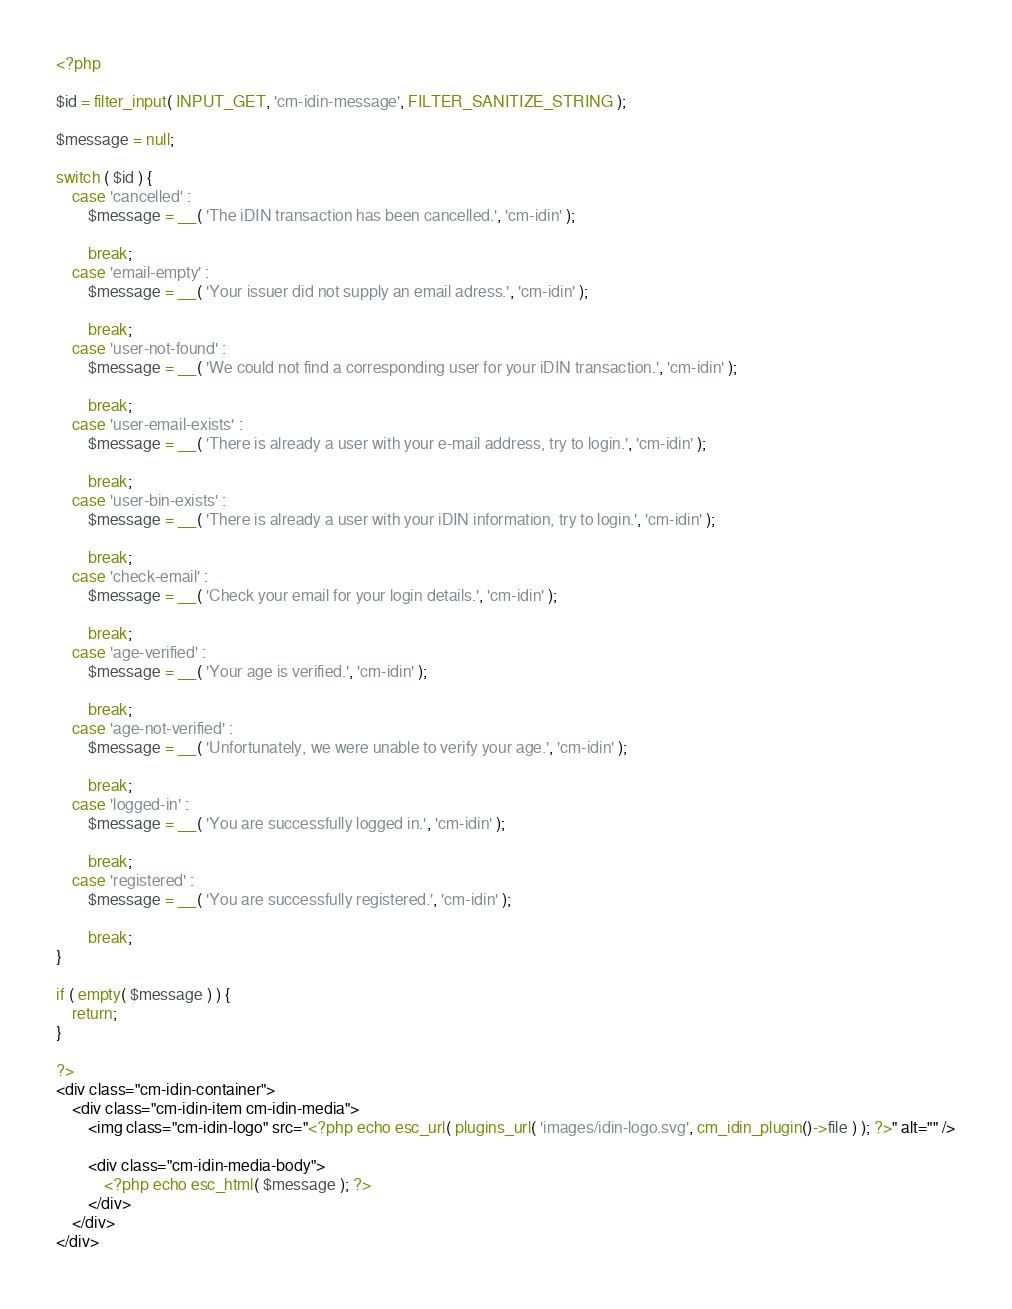<code> <loc_0><loc_0><loc_500><loc_500><_PHP_><?php

$id = filter_input( INPUT_GET, 'cm-idin-message', FILTER_SANITIZE_STRING );

$message = null;

switch ( $id ) {
	case 'cancelled' :
		$message = __( 'The iDIN transaction has been cancelled.', 'cm-idin' );

		break;
	case 'email-empty' :
		$message = __( 'Your issuer did not supply an email adress.', 'cm-idin' );

		break;
	case 'user-not-found' :
		$message = __( 'We could not find a corresponding user for your iDIN transaction.', 'cm-idin' );

		break;
	case 'user-email-exists' :
		$message = __( 'There is already a user with your e-mail address, try to login.', 'cm-idin' );

		break;
	case 'user-bin-exists' :
		$message = __( 'There is already a user with your iDIN information, try to login.', 'cm-idin' );

		break;
	case 'check-email' :
		$message = __( 'Check your email for your login details.', 'cm-idin' );

		break;
	case 'age-verified' :
		$message = __( 'Your age is verified.', 'cm-idin' );

		break;
	case 'age-not-verified' :
		$message = __( 'Unfortunately, we were unable to verify your age.', 'cm-idin' );

		break;
	case 'logged-in' :
		$message = __( 'You are successfully logged in.', 'cm-idin' );

		break;
	case 'registered' :
		$message = __( 'You are successfully registered.', 'cm-idin' );

		break;
}

if ( empty( $message ) ) {
	return;
}

?>
<div class="cm-idin-container">
	<div class="cm-idin-item cm-idin-media">
		<img class="cm-idin-logo" src="<?php echo esc_url( plugins_url( 'images/idin-logo.svg', cm_idin_plugin()->file ) ); ?>" alt="" />

		<div class="cm-idin-media-body">
			<?php echo esc_html( $message ); ?>
		</div>
	</div>
</div>
</code> 